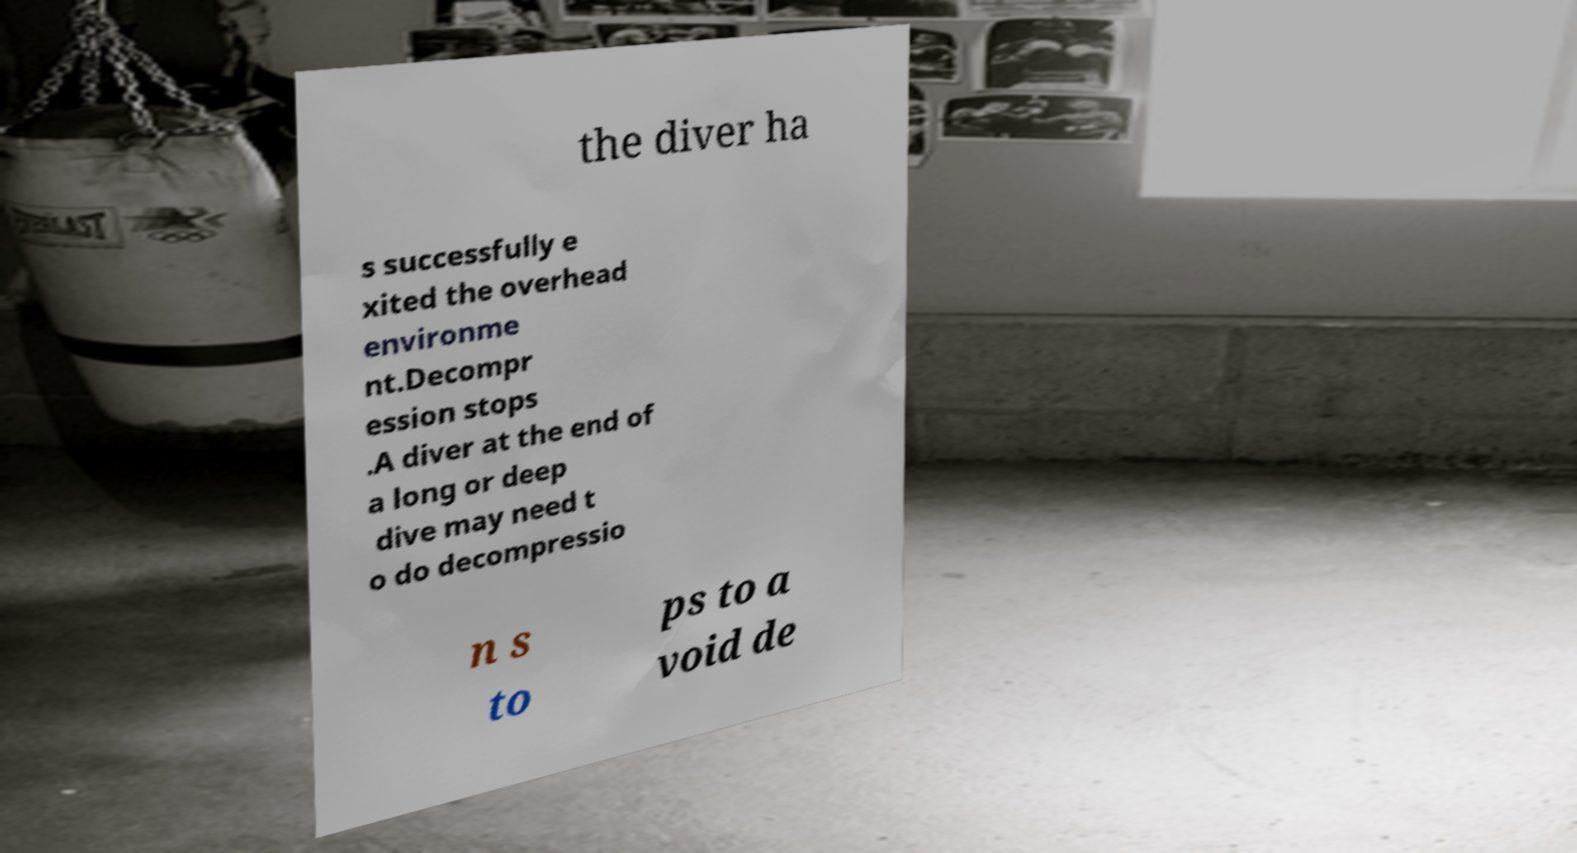I need the written content from this picture converted into text. Can you do that? the diver ha s successfully e xited the overhead environme nt.Decompr ession stops .A diver at the end of a long or deep dive may need t o do decompressio n s to ps to a void de 